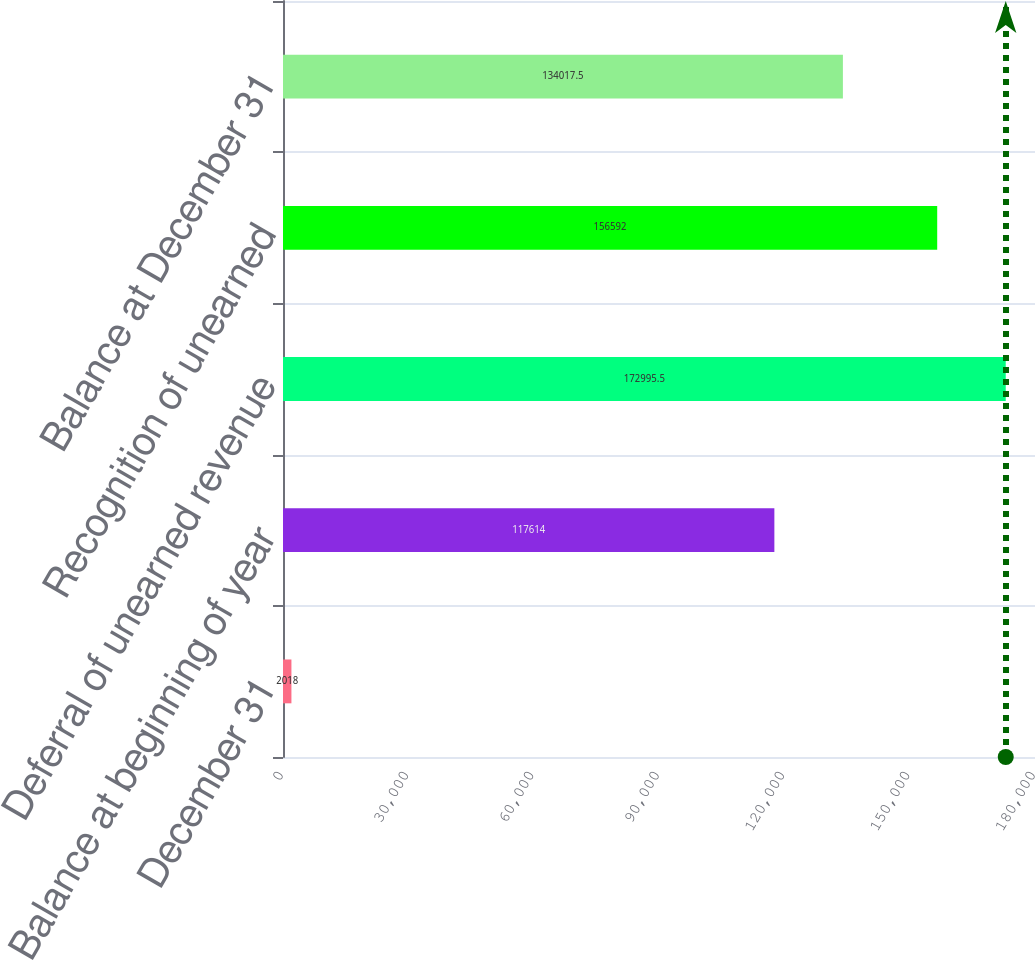Convert chart to OTSL. <chart><loc_0><loc_0><loc_500><loc_500><bar_chart><fcel>December 31<fcel>Balance at beginning of year<fcel>Deferral of unearned revenue<fcel>Recognition of unearned<fcel>Balance at December 31<nl><fcel>2018<fcel>117614<fcel>172996<fcel>156592<fcel>134018<nl></chart> 